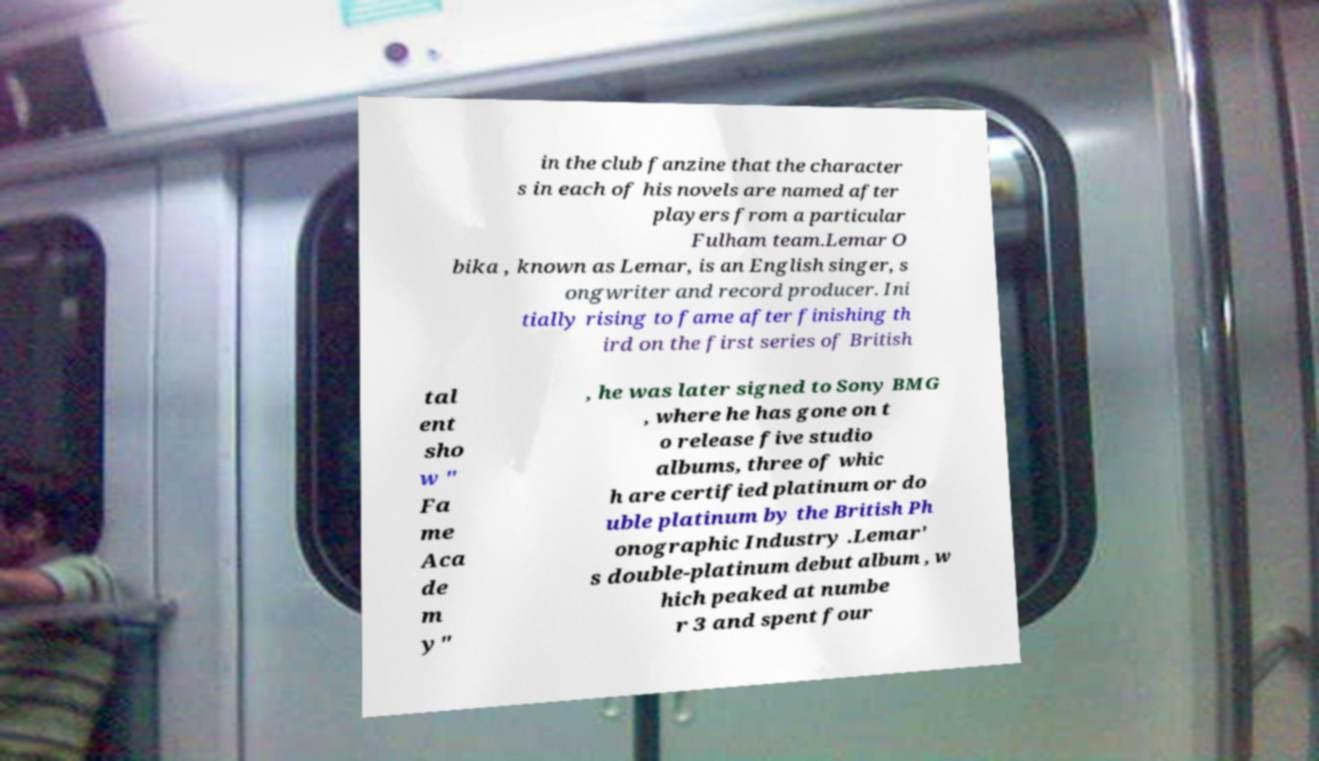Can you accurately transcribe the text from the provided image for me? in the club fanzine that the character s in each of his novels are named after players from a particular Fulham team.Lemar O bika , known as Lemar, is an English singer, s ongwriter and record producer. Ini tially rising to fame after finishing th ird on the first series of British tal ent sho w " Fa me Aca de m y" , he was later signed to Sony BMG , where he has gone on t o release five studio albums, three of whic h are certified platinum or do uble platinum by the British Ph onographic Industry .Lemar' s double-platinum debut album , w hich peaked at numbe r 3 and spent four 